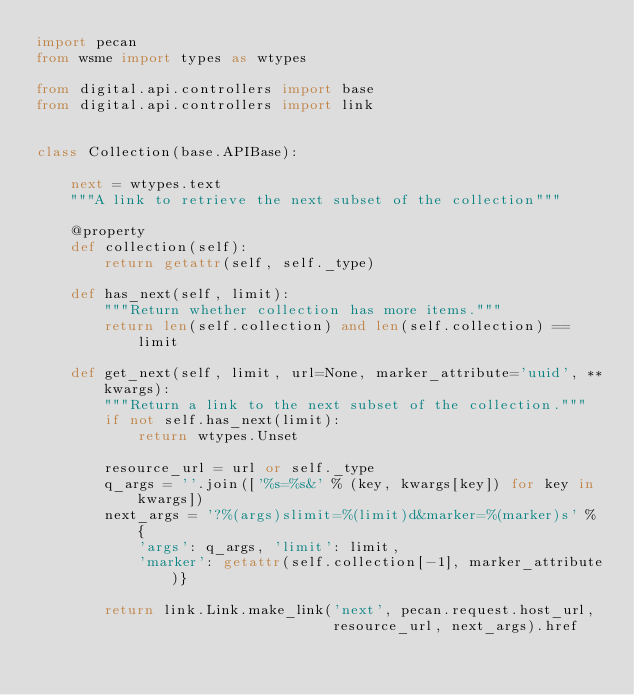Convert code to text. <code><loc_0><loc_0><loc_500><loc_500><_Python_>import pecan
from wsme import types as wtypes

from digital.api.controllers import base
from digital.api.controllers import link


class Collection(base.APIBase):

    next = wtypes.text
    """A link to retrieve the next subset of the collection"""

    @property
    def collection(self):
        return getattr(self, self._type)

    def has_next(self, limit):
        """Return whether collection has more items."""
        return len(self.collection) and len(self.collection) == limit

    def get_next(self, limit, url=None, marker_attribute='uuid', **kwargs):
        """Return a link to the next subset of the collection."""
        if not self.has_next(limit):
            return wtypes.Unset

        resource_url = url or self._type
        q_args = ''.join(['%s=%s&' % (key, kwargs[key]) for key in kwargs])
        next_args = '?%(args)slimit=%(limit)d&marker=%(marker)s' % {
            'args': q_args, 'limit': limit,
            'marker': getattr(self.collection[-1], marker_attribute)}

        return link.Link.make_link('next', pecan.request.host_url,
                                   resource_url, next_args).href
</code> 